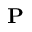Convert formula to latex. <formula><loc_0><loc_0><loc_500><loc_500>\mathbf P</formula> 